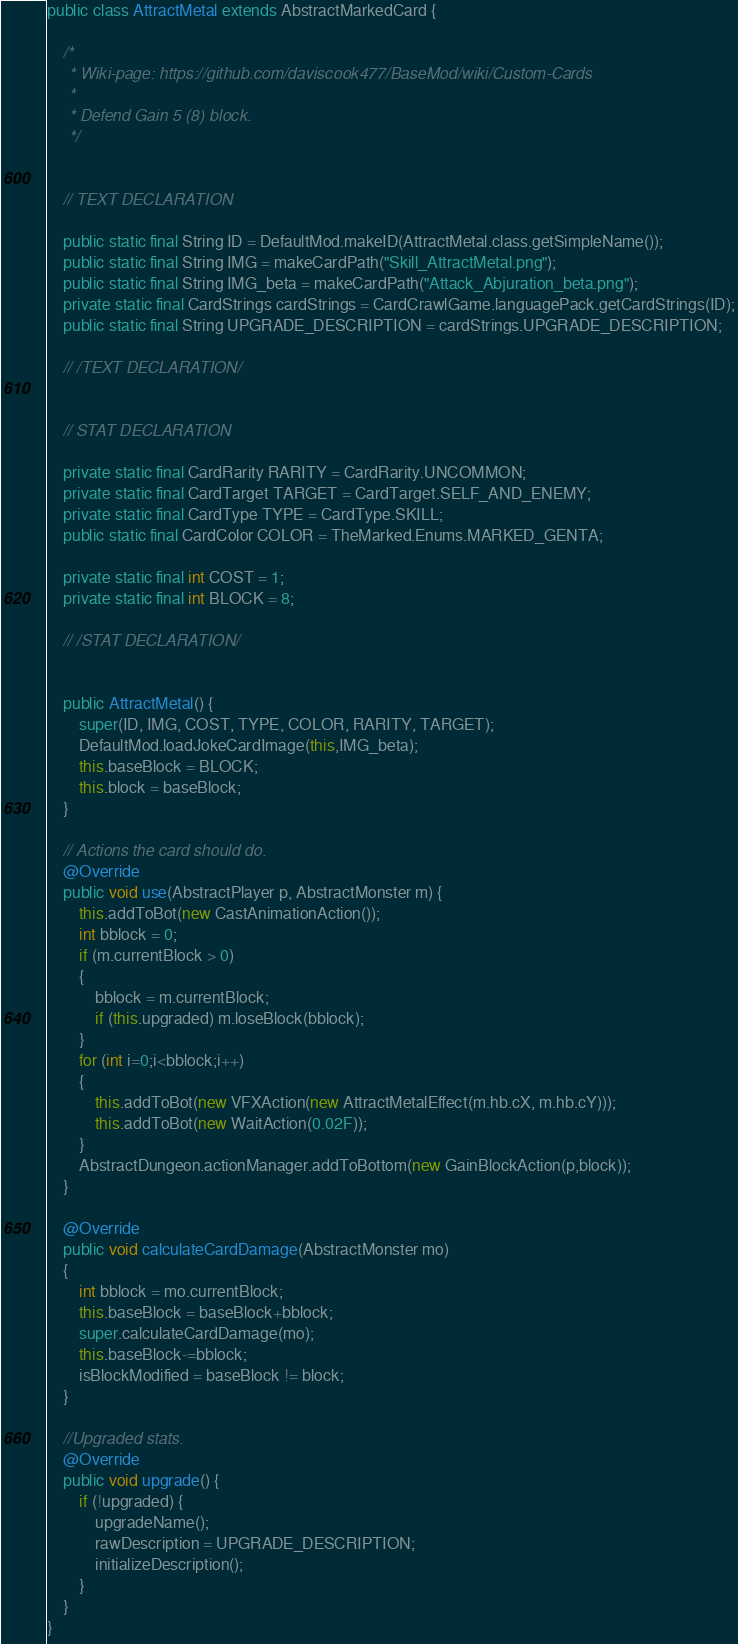Convert code to text. <code><loc_0><loc_0><loc_500><loc_500><_Java_>public class AttractMetal extends AbstractMarkedCard {

    /*
     * Wiki-page: https://github.com/daviscook477/BaseMod/wiki/Custom-Cards
     *
     * Defend Gain 5 (8) block.
     */


    // TEXT DECLARATION

    public static final String ID = DefaultMod.makeID(AttractMetal.class.getSimpleName());
    public static final String IMG = makeCardPath("Skill_AttractMetal.png");
    public static final String IMG_beta = makeCardPath("Attack_Abjuration_beta.png");
    private static final CardStrings cardStrings = CardCrawlGame.languagePack.getCardStrings(ID);
    public static final String UPGRADE_DESCRIPTION = cardStrings.UPGRADE_DESCRIPTION;

    // /TEXT DECLARATION/


    // STAT DECLARATION

    private static final CardRarity RARITY = CardRarity.UNCOMMON;
    private static final CardTarget TARGET = CardTarget.SELF_AND_ENEMY;
    private static final CardType TYPE = CardType.SKILL;
    public static final CardColor COLOR = TheMarked.Enums.MARKED_GENTA;

    private static final int COST = 1;
    private static final int BLOCK = 8;

    // /STAT DECLARATION/


    public AttractMetal() {
        super(ID, IMG, COST, TYPE, COLOR, RARITY, TARGET);
        DefaultMod.loadJokeCardImage(this,IMG_beta);
        this.baseBlock = BLOCK;
        this.block = baseBlock;
    }

    // Actions the card should do.
    @Override
    public void use(AbstractPlayer p, AbstractMonster m) {
        this.addToBot(new CastAnimationAction());
        int bblock = 0;
        if (m.currentBlock > 0)
        {
            bblock = m.currentBlock;
            if (this.upgraded) m.loseBlock(bblock);
        }
        for (int i=0;i<bblock;i++)
        {
            this.addToBot(new VFXAction(new AttractMetalEffect(m.hb.cX, m.hb.cY)));
            this.addToBot(new WaitAction(0.02F));
        }
        AbstractDungeon.actionManager.addToBottom(new GainBlockAction(p,block));
    }

    @Override
    public void calculateCardDamage(AbstractMonster mo)
    {
        int bblock = mo.currentBlock;
        this.baseBlock = baseBlock+bblock;
        super.calculateCardDamage(mo);
        this.baseBlock-=bblock;
        isBlockModified = baseBlock != block;
    }

    //Upgraded stats.
    @Override
    public void upgrade() {
        if (!upgraded) {
            upgradeName();
            rawDescription = UPGRADE_DESCRIPTION;
            initializeDescription();
        }
    }
}
</code> 